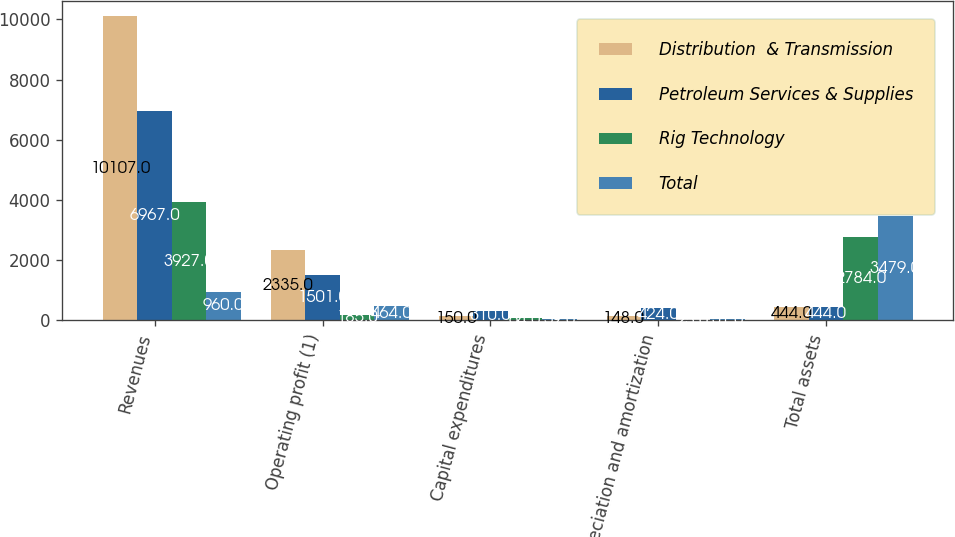<chart> <loc_0><loc_0><loc_500><loc_500><stacked_bar_chart><ecel><fcel>Revenues<fcel>Operating profit (1)<fcel>Capital expenditures<fcel>Depreciation and amortization<fcel>Total assets<nl><fcel>Distribution  & Transmission<fcel>10107<fcel>2335<fcel>150<fcel>148<fcel>444<nl><fcel>Petroleum Services & Supplies<fcel>6967<fcel>1501<fcel>310<fcel>424<fcel>444<nl><fcel>Rig Technology<fcel>3927<fcel>185<fcel>64<fcel>25<fcel>2784<nl><fcel>Total<fcel>960<fcel>464<fcel>59<fcel>31<fcel>3479<nl></chart> 